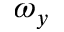Convert formula to latex. <formula><loc_0><loc_0><loc_500><loc_500>\omega _ { y }</formula> 